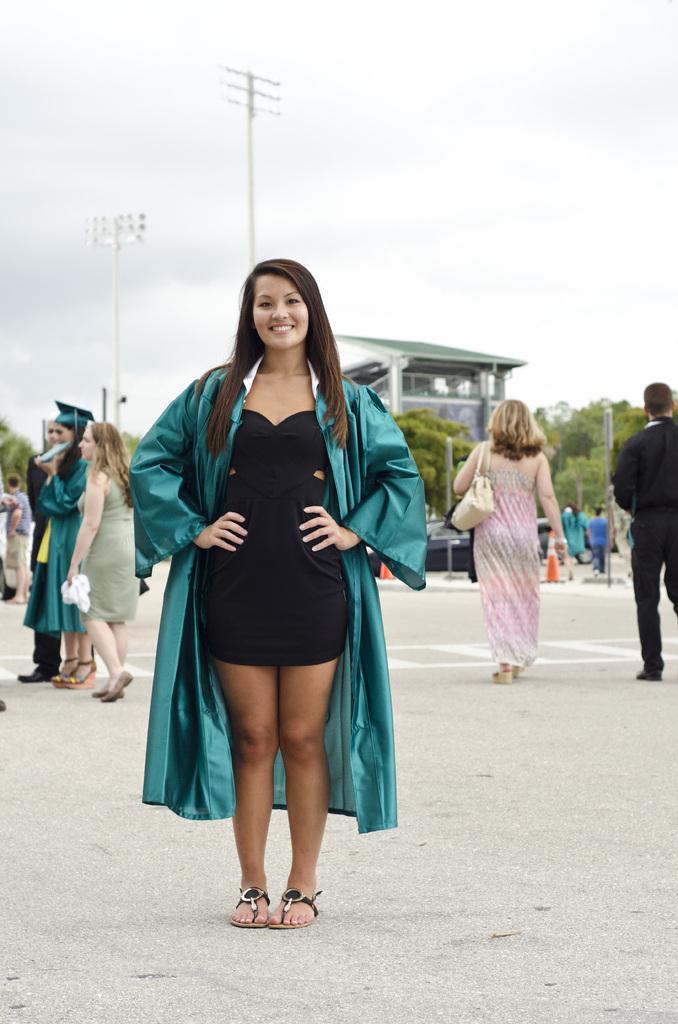Describe this image in one or two sentences. In the middle of the image a woman is standing and smiling. Behind her few people are standing and walking and there are some trees and poles and buildings. Top of the image there are some clouds and sky. 